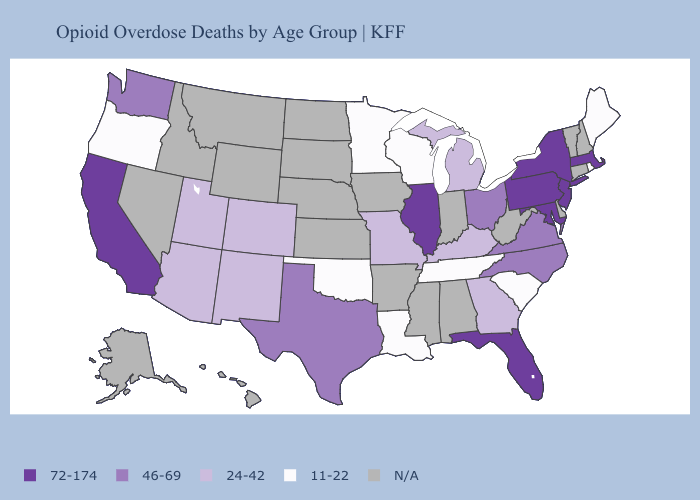Name the states that have a value in the range 72-174?
Keep it brief. California, Florida, Illinois, Maryland, Massachusetts, New Jersey, New York, Pennsylvania. What is the lowest value in the USA?
Quick response, please. 11-22. Does Minnesota have the lowest value in the USA?
Keep it brief. Yes. Which states have the lowest value in the USA?
Give a very brief answer. Louisiana, Maine, Minnesota, Oklahoma, Oregon, Rhode Island, South Carolina, Tennessee, Wisconsin. What is the value of Georgia?
Give a very brief answer. 24-42. What is the lowest value in the Northeast?
Keep it brief. 11-22. What is the highest value in states that border Arkansas?
Answer briefly. 46-69. What is the value of Louisiana?
Quick response, please. 11-22. Does Pennsylvania have the highest value in the USA?
Quick response, please. Yes. What is the lowest value in the USA?
Concise answer only. 11-22. Name the states that have a value in the range 46-69?
Write a very short answer. North Carolina, Ohio, Texas, Virginia, Washington. What is the lowest value in the Northeast?
Answer briefly. 11-22. Name the states that have a value in the range 11-22?
Keep it brief. Louisiana, Maine, Minnesota, Oklahoma, Oregon, Rhode Island, South Carolina, Tennessee, Wisconsin. What is the value of Wyoming?
Give a very brief answer. N/A. 